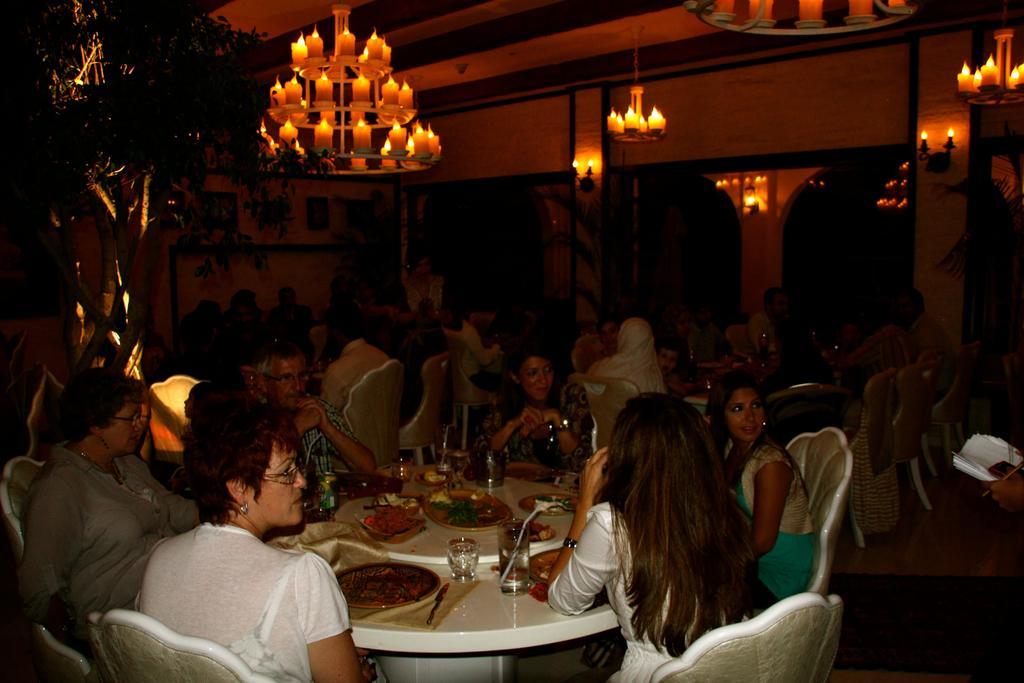How would you summarize this image in a sentence or two? This picture shows a group of people seated on the chairs and we see few food items and glasses on the table and we see a chandelier light on the table 